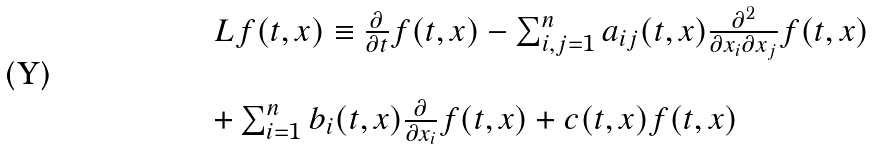Convert formula to latex. <formula><loc_0><loc_0><loc_500><loc_500>\begin{array} { l l } L f ( t , x ) \equiv \frac { \partial } { \partial t } f ( t , x ) - \sum _ { i , j = 1 } ^ { n } a _ { i j } ( t , x ) \frac { \partial ^ { 2 } } { \partial x _ { i } \partial x _ { j } } f ( t , x ) \\ \\ + \sum _ { i = 1 } ^ { n } b _ { i } ( t , x ) \frac { \partial } { \partial x _ { i } } f ( t , x ) + c ( t , x ) f ( t , x ) \end{array}</formula> 